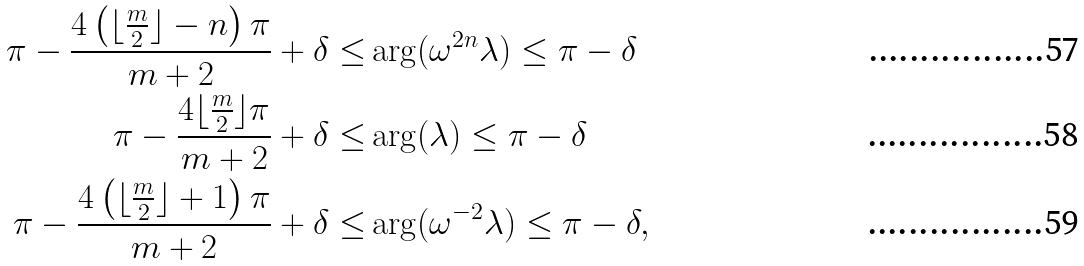<formula> <loc_0><loc_0><loc_500><loc_500>\pi - \frac { 4 \left ( \lfloor \frac { m } { 2 } \rfloor - n \right ) \pi } { m + 2 } + \delta \leq & \arg ( \omega ^ { 2 n } \lambda ) \leq \pi - \delta \\ \pi - \frac { 4 \lfloor \frac { m } { 2 } \rfloor \pi } { m + 2 } + \delta \leq & \arg ( \lambda ) \leq \pi - \delta \\ \pi - \frac { 4 \left ( \lfloor \frac { m } { 2 } \rfloor + 1 \right ) \pi } { m + 2 } + \delta \leq & \arg ( \omega ^ { - 2 } \lambda ) \leq \pi - \delta ,</formula> 